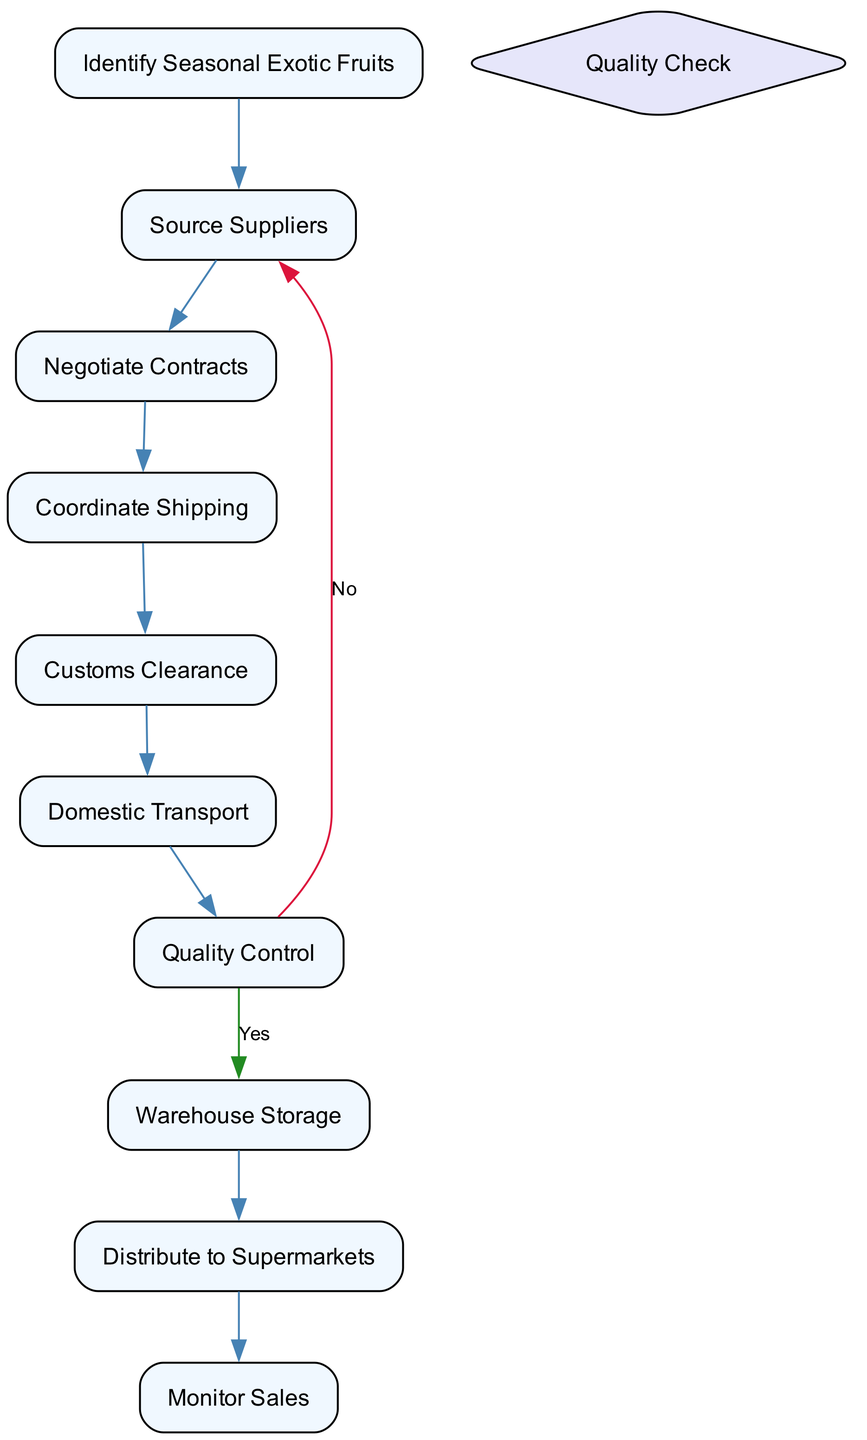What is the first activity in the diagram? The diagram starts with the first activity node, which is "Identify Seasonal Exotic Fruits". This can be identified by looking at the flow that comes from  the starting point of the diagram.
Answer: Identify Seasonal Exotic Fruits How many activities are there in the diagram? By reviewing the list of activities provided in the data, we can count a total of 10 distinct activities.
Answer: 10 What happens if the fruits do not meet quality standards? The flow from the "Quality Control" decision point shows a path leading back to "Source Suppliers" if the fruits do not meet quality standards, indicating an action taken when quality is insufficient.
Answer: Source Suppliers What is the last activity in the diagram? The end of the flow leads to "Monitor Sales", indicating this is the final activity carried out after "Distribute to Supermarkets".
Answer: Monitor Sales What decision point is present in the diagram? The key decision point in this activity diagram is labeled as "Quality Check", which determines whether the fruits meet quality standards after arrival.
Answer: Quality Check Describe the flow after "Coordinate Shipping". After "Coordinate Shipping", the next step in the flow directed to "Customs Clearance", indicating that customs procedures are addressed following shipping arrangements.
Answer: Customs Clearance How do the exotic fruits reach the supermarkets? The path through the diagram shows that after going through "Warehouse Storage", the fruits are "Distribute to Supermarkets", indicating the final distribution process to retail locations.
Answer: Distribute to Supermarkets What is the relationship between "Quality Control" and "Warehouse Storage"? The relationship is conditional; if the "Quality Control" passes the quality check, the flow continues to "Warehouse Storage", indicating a successful inspection result.
Answer: Conditional relationship What is the purpose of "Monitor Sales"? "Monitor Sales" serves to track sales performance and gather customer feedback on the exotic fruits after they have been distributed to the supermarkets.
Answer: Track sales performance 